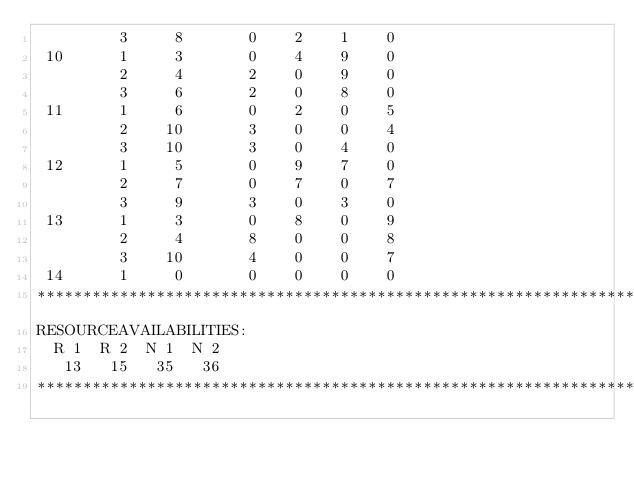<code> <loc_0><loc_0><loc_500><loc_500><_ObjectiveC_>         3     8       0    2    1    0
 10      1     3       0    4    9    0
         2     4       2    0    9    0
         3     6       2    0    8    0
 11      1     6       0    2    0    5
         2    10       3    0    0    4
         3    10       3    0    4    0
 12      1     5       0    9    7    0
         2     7       0    7    0    7
         3     9       3    0    3    0
 13      1     3       0    8    0    9
         2     4       8    0    0    8
         3    10       4    0    0    7
 14      1     0       0    0    0    0
************************************************************************
RESOURCEAVAILABILITIES:
  R 1  R 2  N 1  N 2
   13   15   35   36
************************************************************************
</code> 